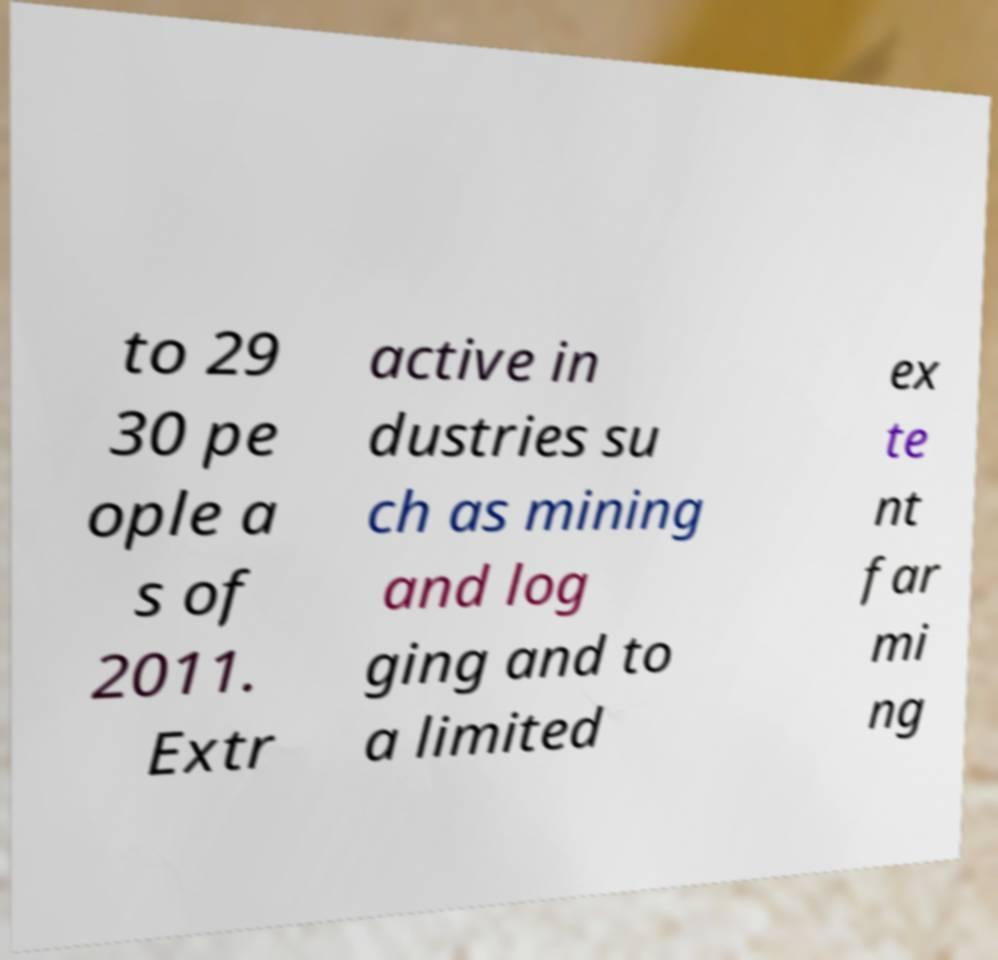Could you assist in decoding the text presented in this image and type it out clearly? to 29 30 pe ople a s of 2011. Extr active in dustries su ch as mining and log ging and to a limited ex te nt far mi ng 